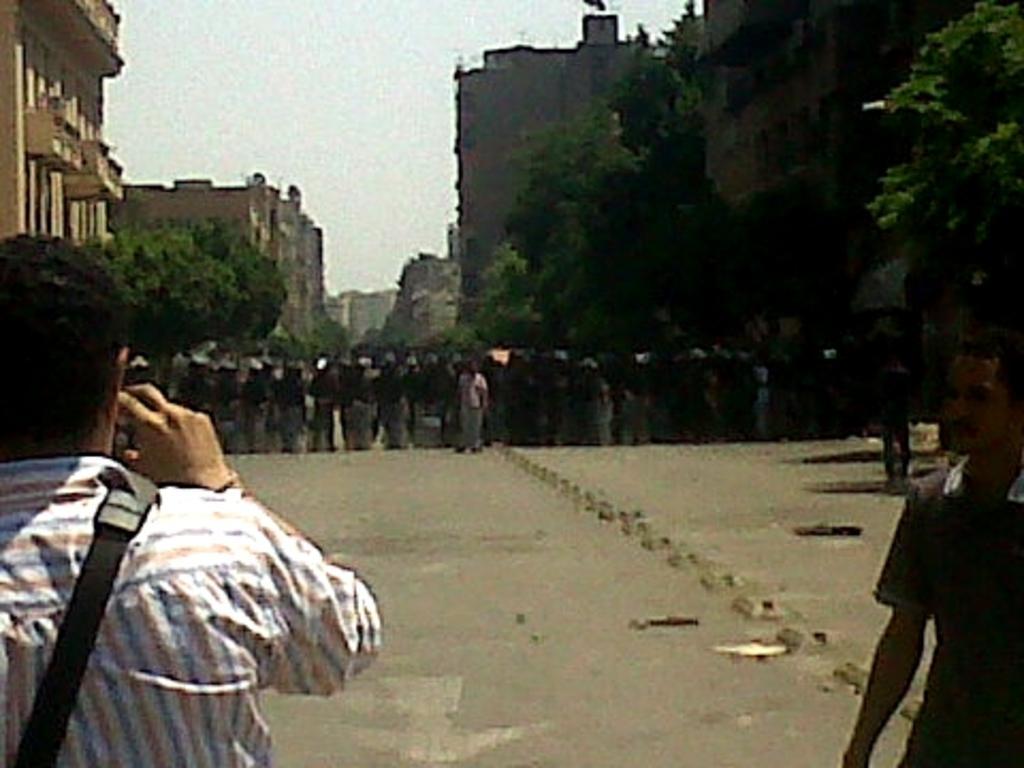Can you describe this image briefly? Here we can see two persons. There are trees, buildings, and group of people standing on the road. In the background there is sky. 